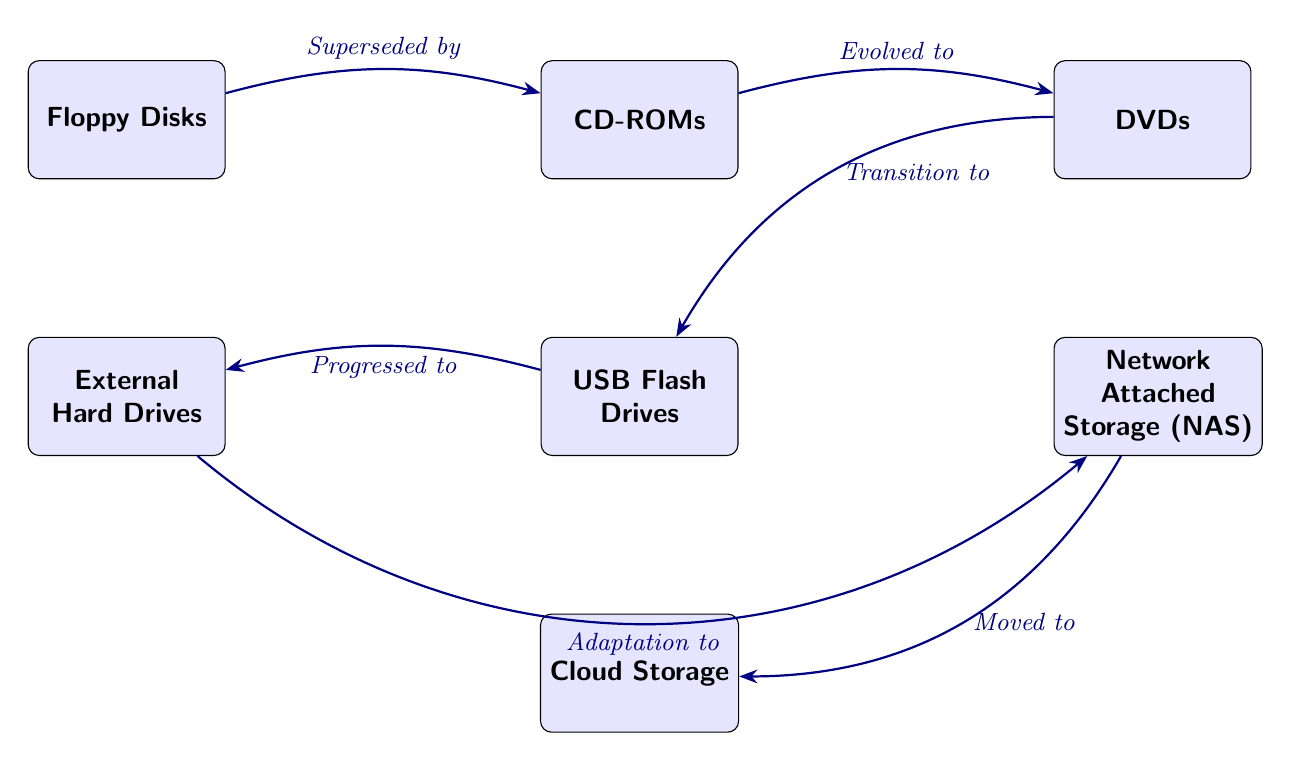What is the first node in the diagram? The diagram starts with the leftmost node, which is labeled “Floppy Disks.”
Answer: Floppy Disks How many types of storage technologies are shown in the diagram? Counting all the nodes, there are a total of 7 storage technologies represented: Floppy Disks, CD-ROMs, DVDs, USB Flash Drives, External Hard Drives, Network Attached Storage (NAS), and Cloud Storage.
Answer: 7 Which storage technology evolved into DVDs? The diagram shows an arrow from CD-ROMs to DVDs, indicating that CD-ROMs evolved into DVDs.
Answer: CD-ROMs What is the relationship between USB Flash Drives and External Hard Drives? USB Flash Drives progressed to External Hard Drives, as indicated by the arrow connecting these two nodes in the diagram.
Answer: Progressed to Which technology does Network Attached Storage (NAS) move to? The arrow from Network Attached Storage (NAS) points to Cloud Storage, indicating that NAS moved to Cloud Storage.
Answer: Cloud Storage What technology comes after DVDs in the evolution according to the diagram? According to the diagram, the technology that comes after DVDs is USB Flash Drives, as indicated by the arrow between these two nodes.
Answer: USB Flash Drives Which two storage technologies are placed in the same vertical line? USB Flash Drives and Network Attached Storage (NAS) are positioned in a vertical alignment according to the layout of the diagram.
Answer: USB Flash Drives and Network Attached Storage (NAS) What kind of storage does External Hard Drives adapt to? The diagram indicates that External Hard Drives adapt to Network Attached Storage (NAS), as shown by the arrow connecting these two nodes.
Answer: Network Attached Storage (NAS) 